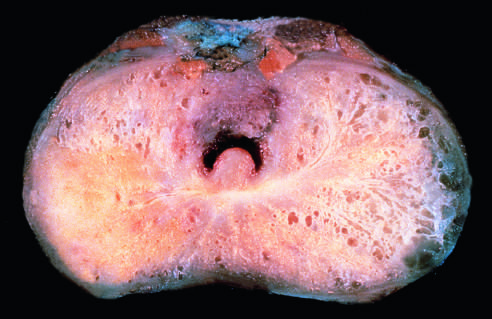s carcinomatous tissue seen on the posterior aspect (lower left)?
Answer the question using a single word or phrase. Yes 